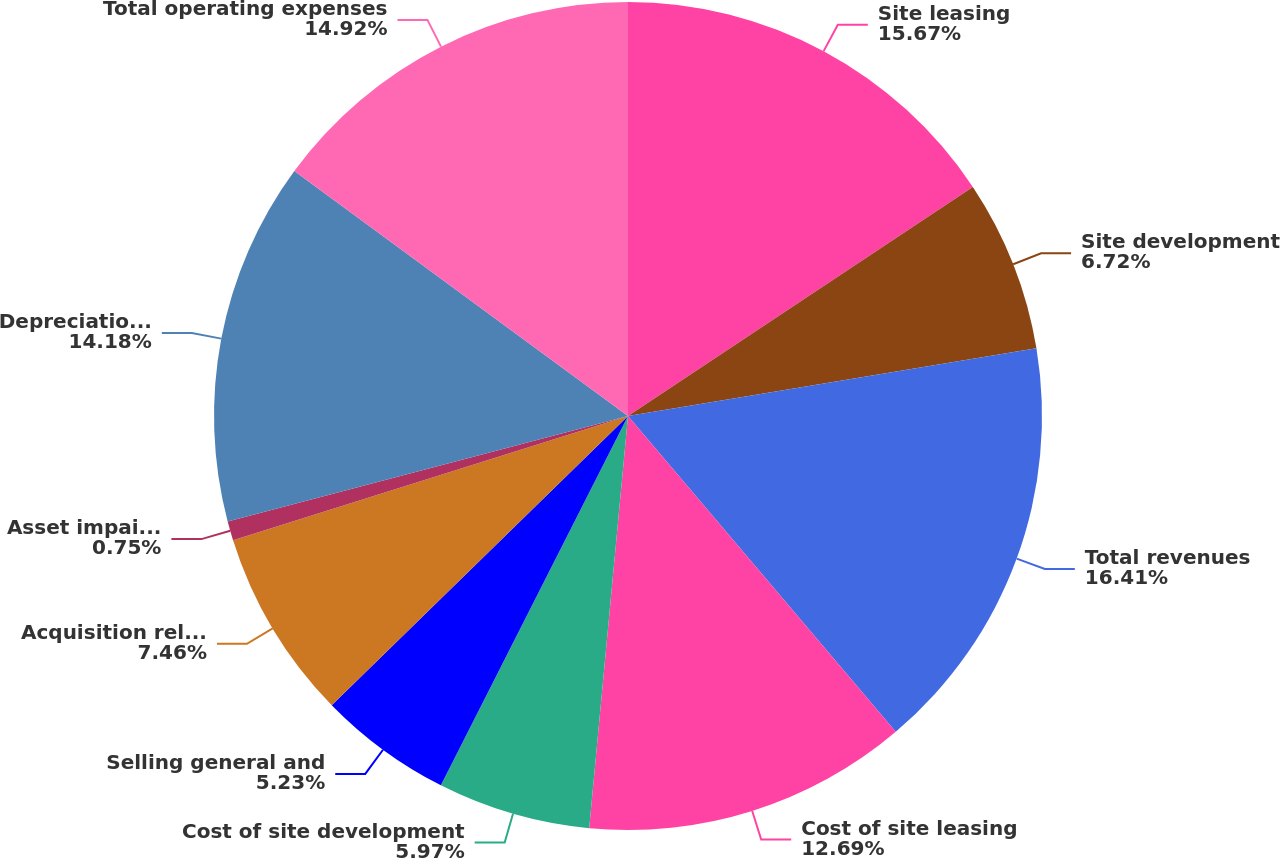<chart> <loc_0><loc_0><loc_500><loc_500><pie_chart><fcel>Site leasing<fcel>Site development<fcel>Total revenues<fcel>Cost of site leasing<fcel>Cost of site development<fcel>Selling general and<fcel>Acquisition related expenses<fcel>Asset impairment and<fcel>Depreciation accretion and<fcel>Total operating expenses<nl><fcel>15.67%<fcel>6.72%<fcel>16.42%<fcel>12.69%<fcel>5.97%<fcel>5.23%<fcel>7.46%<fcel>0.75%<fcel>14.18%<fcel>14.92%<nl></chart> 